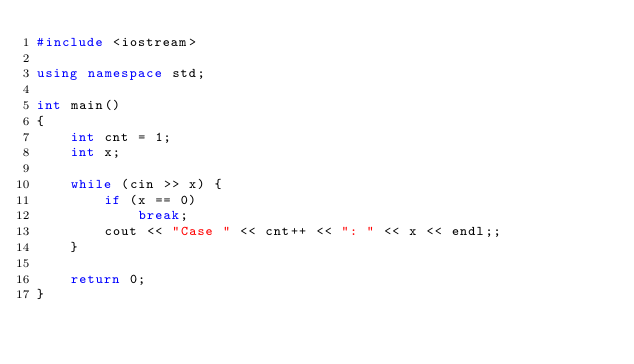<code> <loc_0><loc_0><loc_500><loc_500><_C++_>#include <iostream>

using namespace std;

int main()
{
    int cnt = 1;
    int x;
    
    while (cin >> x) {
        if (x == 0)
            break;
        cout << "Case " << cnt++ << ": " << x << endl;;
    }

    return 0;
}</code> 